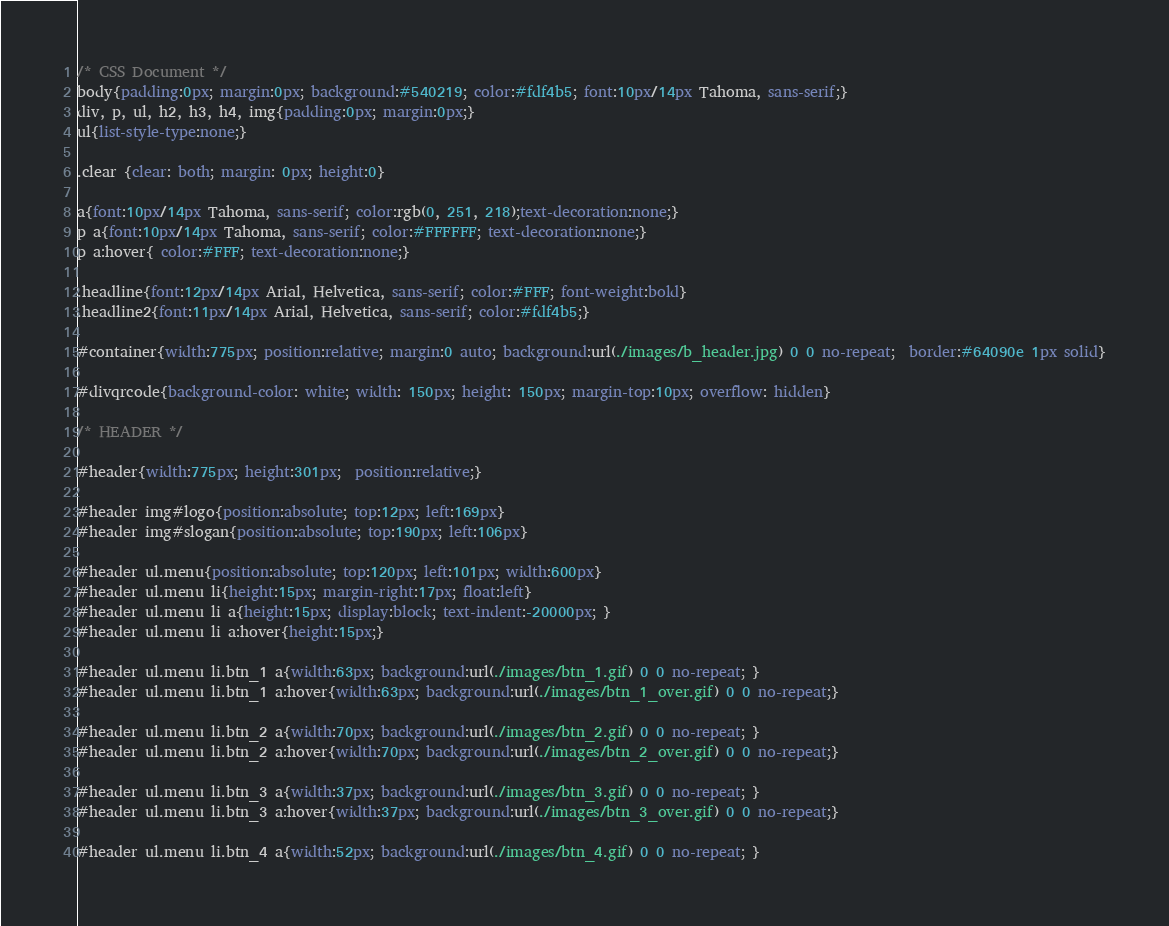Convert code to text. <code><loc_0><loc_0><loc_500><loc_500><_CSS_>/* CSS Document */
body{padding:0px; margin:0px; background:#540219; color:#fdf4b5; font:10px/14px Tahoma, sans-serif;}
div, p, ul, h2, h3, h4, img{padding:0px; margin:0px;}
ul{list-style-type:none;}

.clear {clear: both; margin: 0px; height:0}

a{font:10px/14px Tahoma, sans-serif; color:rgb(0, 251, 218);text-decoration:none;}
p a{font:10px/14px Tahoma, sans-serif; color:#FFFFFF; text-decoration:none;}
p a:hover{ color:#FFF; text-decoration:none;}

.headline{font:12px/14px Arial, Helvetica, sans-serif; color:#FFF; font-weight:bold}
.headline2{font:11px/14px Arial, Helvetica, sans-serif; color:#fdf4b5;}

#container{width:775px; position:relative; margin:0 auto; background:url(./images/b_header.jpg) 0 0 no-repeat;  border:#64090e 1px solid}

#divqrcode{background-color: white; width: 150px; height: 150px; margin-top:10px; overflow: hidden}

/* HEADER */

#header{width:775px; height:301px;  position:relative;}

#header img#logo{position:absolute; top:12px; left:169px}
#header img#slogan{position:absolute; top:190px; left:106px}

#header ul.menu{position:absolute; top:120px; left:101px; width:600px}
#header ul.menu li{height:15px; margin-right:17px; float:left}
#header ul.menu li a{height:15px; display:block; text-indent:-20000px; }
#header ul.menu li a:hover{height:15px;}

#header ul.menu li.btn_1 a{width:63px; background:url(./images/btn_1.gif) 0 0 no-repeat; }
#header ul.menu li.btn_1 a:hover{width:63px; background:url(./images/btn_1_over.gif) 0 0 no-repeat;}

#header ul.menu li.btn_2 a{width:70px; background:url(./images/btn_2.gif) 0 0 no-repeat; }
#header ul.menu li.btn_2 a:hover{width:70px; background:url(./images/btn_2_over.gif) 0 0 no-repeat;}

#header ul.menu li.btn_3 a{width:37px; background:url(./images/btn_3.gif) 0 0 no-repeat; }
#header ul.menu li.btn_3 a:hover{width:37px; background:url(./images/btn_3_over.gif) 0 0 no-repeat;}

#header ul.menu li.btn_4 a{width:52px; background:url(./images/btn_4.gif) 0 0 no-repeat; }</code> 